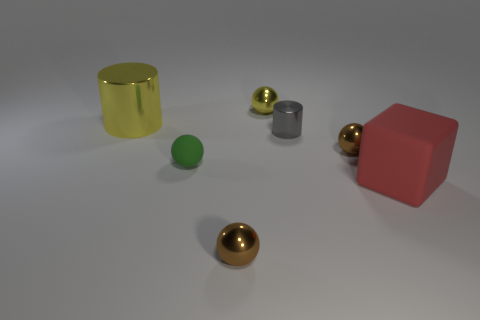Subtract all yellow metallic balls. How many balls are left? 3 Add 3 tiny green things. How many objects exist? 10 Subtract all yellow balls. How many balls are left? 3 Subtract all cylinders. How many objects are left? 5 Subtract all small things. Subtract all yellow metallic things. How many objects are left? 0 Add 7 small metal balls. How many small metal balls are left? 10 Add 7 tiny gray metal spheres. How many tiny gray metal spheres exist? 7 Subtract 0 blue spheres. How many objects are left? 7 Subtract 1 cylinders. How many cylinders are left? 1 Subtract all yellow spheres. Subtract all green cubes. How many spheres are left? 3 